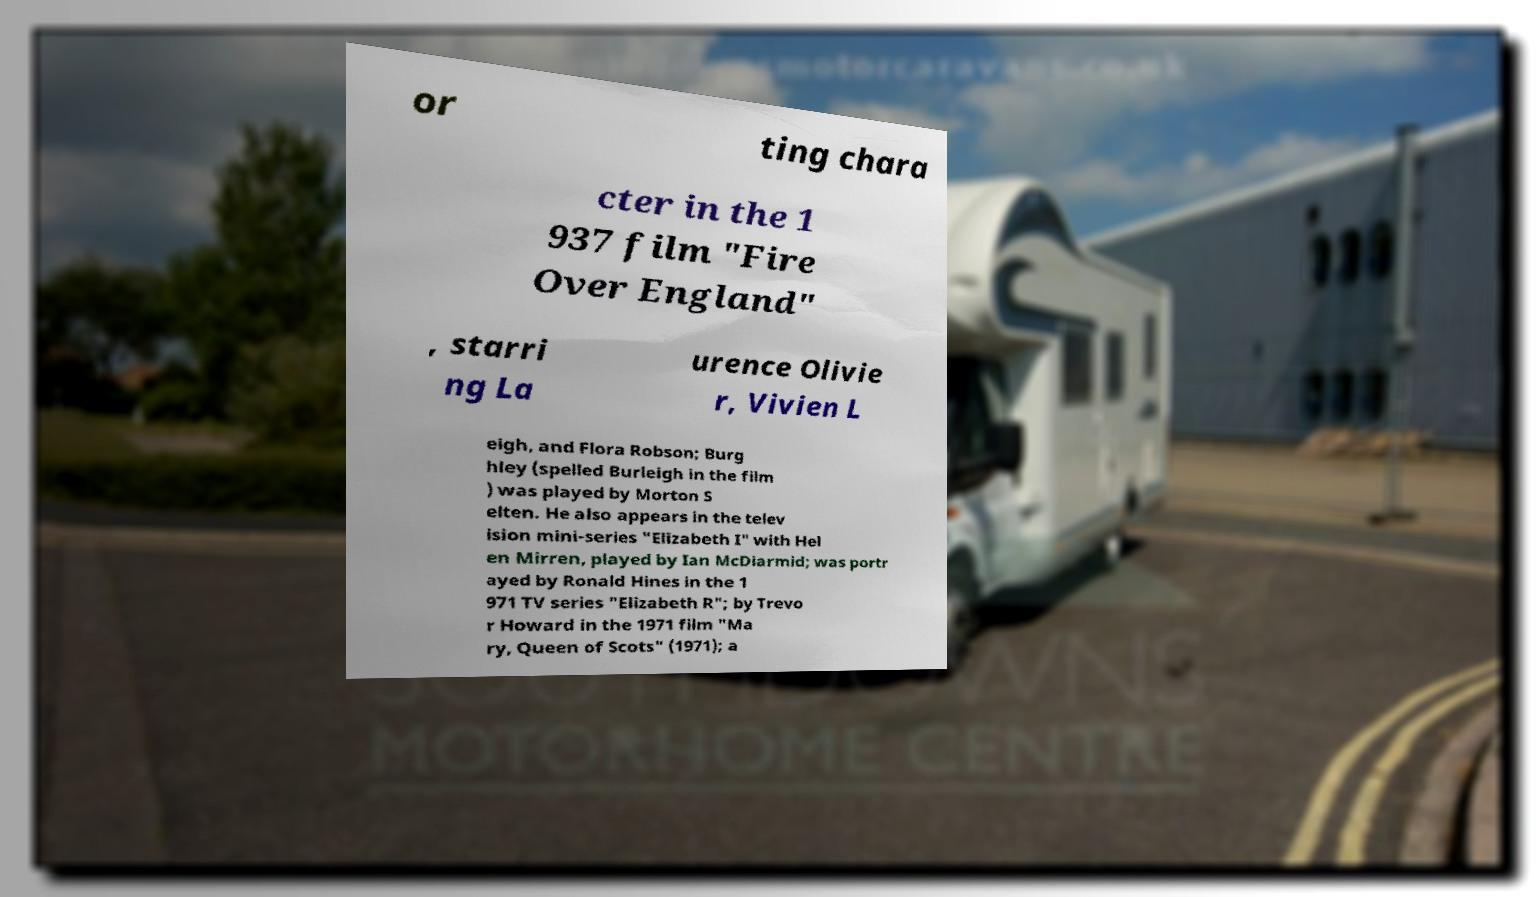Please identify and transcribe the text found in this image. or ting chara cter in the 1 937 film "Fire Over England" , starri ng La urence Olivie r, Vivien L eigh, and Flora Robson; Burg hley (spelled Burleigh in the film ) was played by Morton S elten. He also appears in the telev ision mini-series "Elizabeth I" with Hel en Mirren, played by Ian McDiarmid; was portr ayed by Ronald Hines in the 1 971 TV series "Elizabeth R"; by Trevo r Howard in the 1971 film "Ma ry, Queen of Scots" (1971); a 